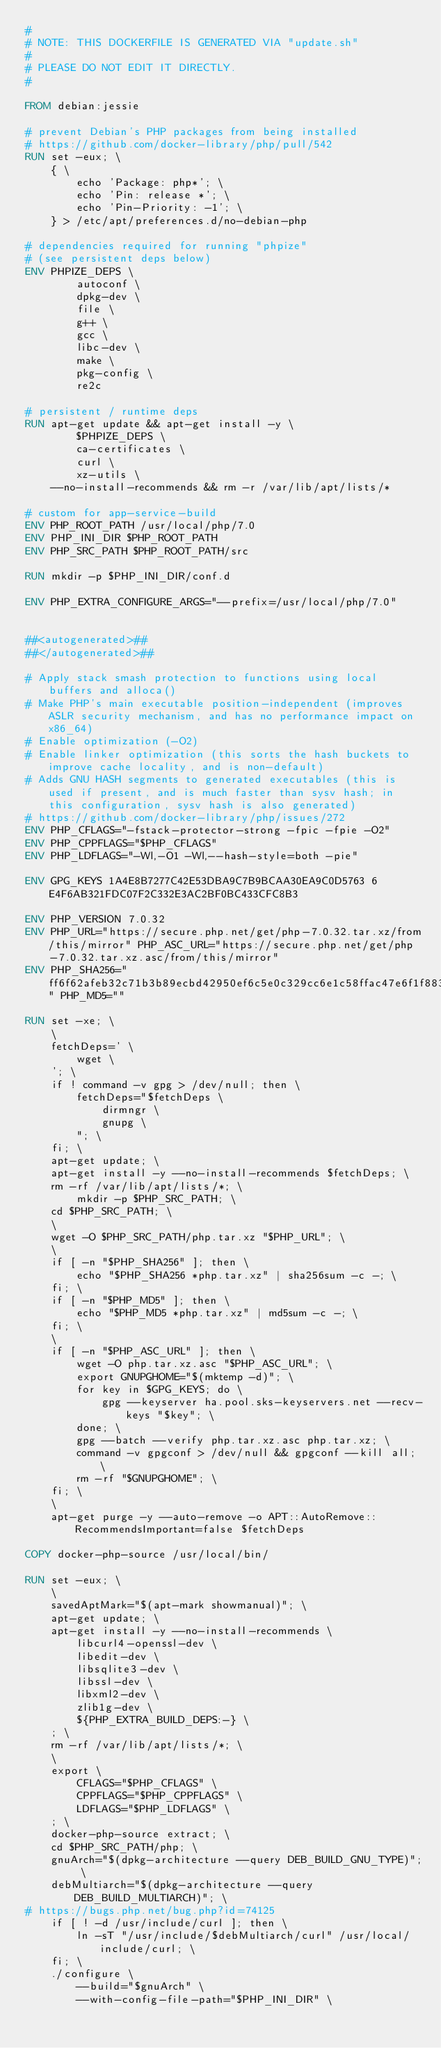<code> <loc_0><loc_0><loc_500><loc_500><_Dockerfile_>#
# NOTE: THIS DOCKERFILE IS GENERATED VIA "update.sh"
#
# PLEASE DO NOT EDIT IT DIRECTLY.
#

FROM debian:jessie

# prevent Debian's PHP packages from being installed
# https://github.com/docker-library/php/pull/542
RUN set -eux; \
	{ \
		echo 'Package: php*'; \
		echo 'Pin: release *'; \
		echo 'Pin-Priority: -1'; \
	} > /etc/apt/preferences.d/no-debian-php

# dependencies required for running "phpize"
# (see persistent deps below)
ENV PHPIZE_DEPS \
		autoconf \
		dpkg-dev \
		file \
		g++ \
		gcc \
		libc-dev \
		make \
		pkg-config \
		re2c

# persistent / runtime deps
RUN apt-get update && apt-get install -y \
		$PHPIZE_DEPS \
		ca-certificates \
		curl \
		xz-utils \
	--no-install-recommends && rm -r /var/lib/apt/lists/*

# custom for app-service-build
ENV PHP_ROOT_PATH /usr/local/php/7.0
ENV PHP_INI_DIR $PHP_ROOT_PATH
ENV PHP_SRC_PATH $PHP_ROOT_PATH/src

RUN mkdir -p $PHP_INI_DIR/conf.d

ENV PHP_EXTRA_CONFIGURE_ARGS="--prefix=/usr/local/php/7.0"


##<autogenerated>##
##</autogenerated>##

# Apply stack smash protection to functions using local buffers and alloca()
# Make PHP's main executable position-independent (improves ASLR security mechanism, and has no performance impact on x86_64)
# Enable optimization (-O2)
# Enable linker optimization (this sorts the hash buckets to improve cache locality, and is non-default)
# Adds GNU HASH segments to generated executables (this is used if present, and is much faster than sysv hash; in this configuration, sysv hash is also generated)
# https://github.com/docker-library/php/issues/272
ENV PHP_CFLAGS="-fstack-protector-strong -fpic -fpie -O2"
ENV PHP_CPPFLAGS="$PHP_CFLAGS"
ENV PHP_LDFLAGS="-Wl,-O1 -Wl,--hash-style=both -pie"

ENV GPG_KEYS 1A4E8B7277C42E53DBA9C7B9BCAA30EA9C0D5763 6E4F6AB321FDC07F2C332E3AC2BF0BC433CFC8B3

ENV PHP_VERSION 7.0.32
ENV PHP_URL="https://secure.php.net/get/php-7.0.32.tar.xz/from/this/mirror" PHP_ASC_URL="https://secure.php.net/get/php-7.0.32.tar.xz.asc/from/this/mirror"
ENV PHP_SHA256="ff6f62afeb32c71b3b89ecbd42950ef6c5e0c329cc6e1c58ffac47e6f1f883c4" PHP_MD5=""

RUN set -xe; \
	\
	fetchDeps=' \
		wget \
	'; \
	if ! command -v gpg > /dev/null; then \
		fetchDeps="$fetchDeps \
			dirmngr \
			gnupg \
		"; \
	fi; \
	apt-get update; \
	apt-get install -y --no-install-recommends $fetchDeps; \
	rm -rf /var/lib/apt/lists/*; \
        mkdir -p $PHP_SRC_PATH; \
	cd $PHP_SRC_PATH; \
	\
	wget -O $PHP_SRC_PATH/php.tar.xz "$PHP_URL"; \
	\
	if [ -n "$PHP_SHA256" ]; then \
		echo "$PHP_SHA256 *php.tar.xz" | sha256sum -c -; \
	fi; \
	if [ -n "$PHP_MD5" ]; then \
		echo "$PHP_MD5 *php.tar.xz" | md5sum -c -; \
	fi; \
	\
	if [ -n "$PHP_ASC_URL" ]; then \
		wget -O php.tar.xz.asc "$PHP_ASC_URL"; \
		export GNUPGHOME="$(mktemp -d)"; \
		for key in $GPG_KEYS; do \
			gpg --keyserver ha.pool.sks-keyservers.net --recv-keys "$key"; \
		done; \
		gpg --batch --verify php.tar.xz.asc php.tar.xz; \
		command -v gpgconf > /dev/null && gpgconf --kill all; \
		rm -rf "$GNUPGHOME"; \
	fi; \
	\
	apt-get purge -y --auto-remove -o APT::AutoRemove::RecommendsImportant=false $fetchDeps

COPY docker-php-source /usr/local/bin/

RUN set -eux; \
	\
	savedAptMark="$(apt-mark showmanual)"; \
	apt-get update; \
	apt-get install -y --no-install-recommends \
		libcurl4-openssl-dev \
		libedit-dev \
		libsqlite3-dev \
		libssl-dev \
		libxml2-dev \
		zlib1g-dev \
		${PHP_EXTRA_BUILD_DEPS:-} \
	; \
	rm -rf /var/lib/apt/lists/*; \
	\
	export \
		CFLAGS="$PHP_CFLAGS" \
		CPPFLAGS="$PHP_CPPFLAGS" \
		LDFLAGS="$PHP_LDFLAGS" \
	; \
	docker-php-source extract; \
	cd $PHP_SRC_PATH/php; \
	gnuArch="$(dpkg-architecture --query DEB_BUILD_GNU_TYPE)"; \
	debMultiarch="$(dpkg-architecture --query DEB_BUILD_MULTIARCH)"; \
# https://bugs.php.net/bug.php?id=74125
	if [ ! -d /usr/include/curl ]; then \
		ln -sT "/usr/include/$debMultiarch/curl" /usr/local/include/curl; \
	fi; \
	./configure \
		--build="$gnuArch" \
		--with-config-file-path="$PHP_INI_DIR" \</code> 